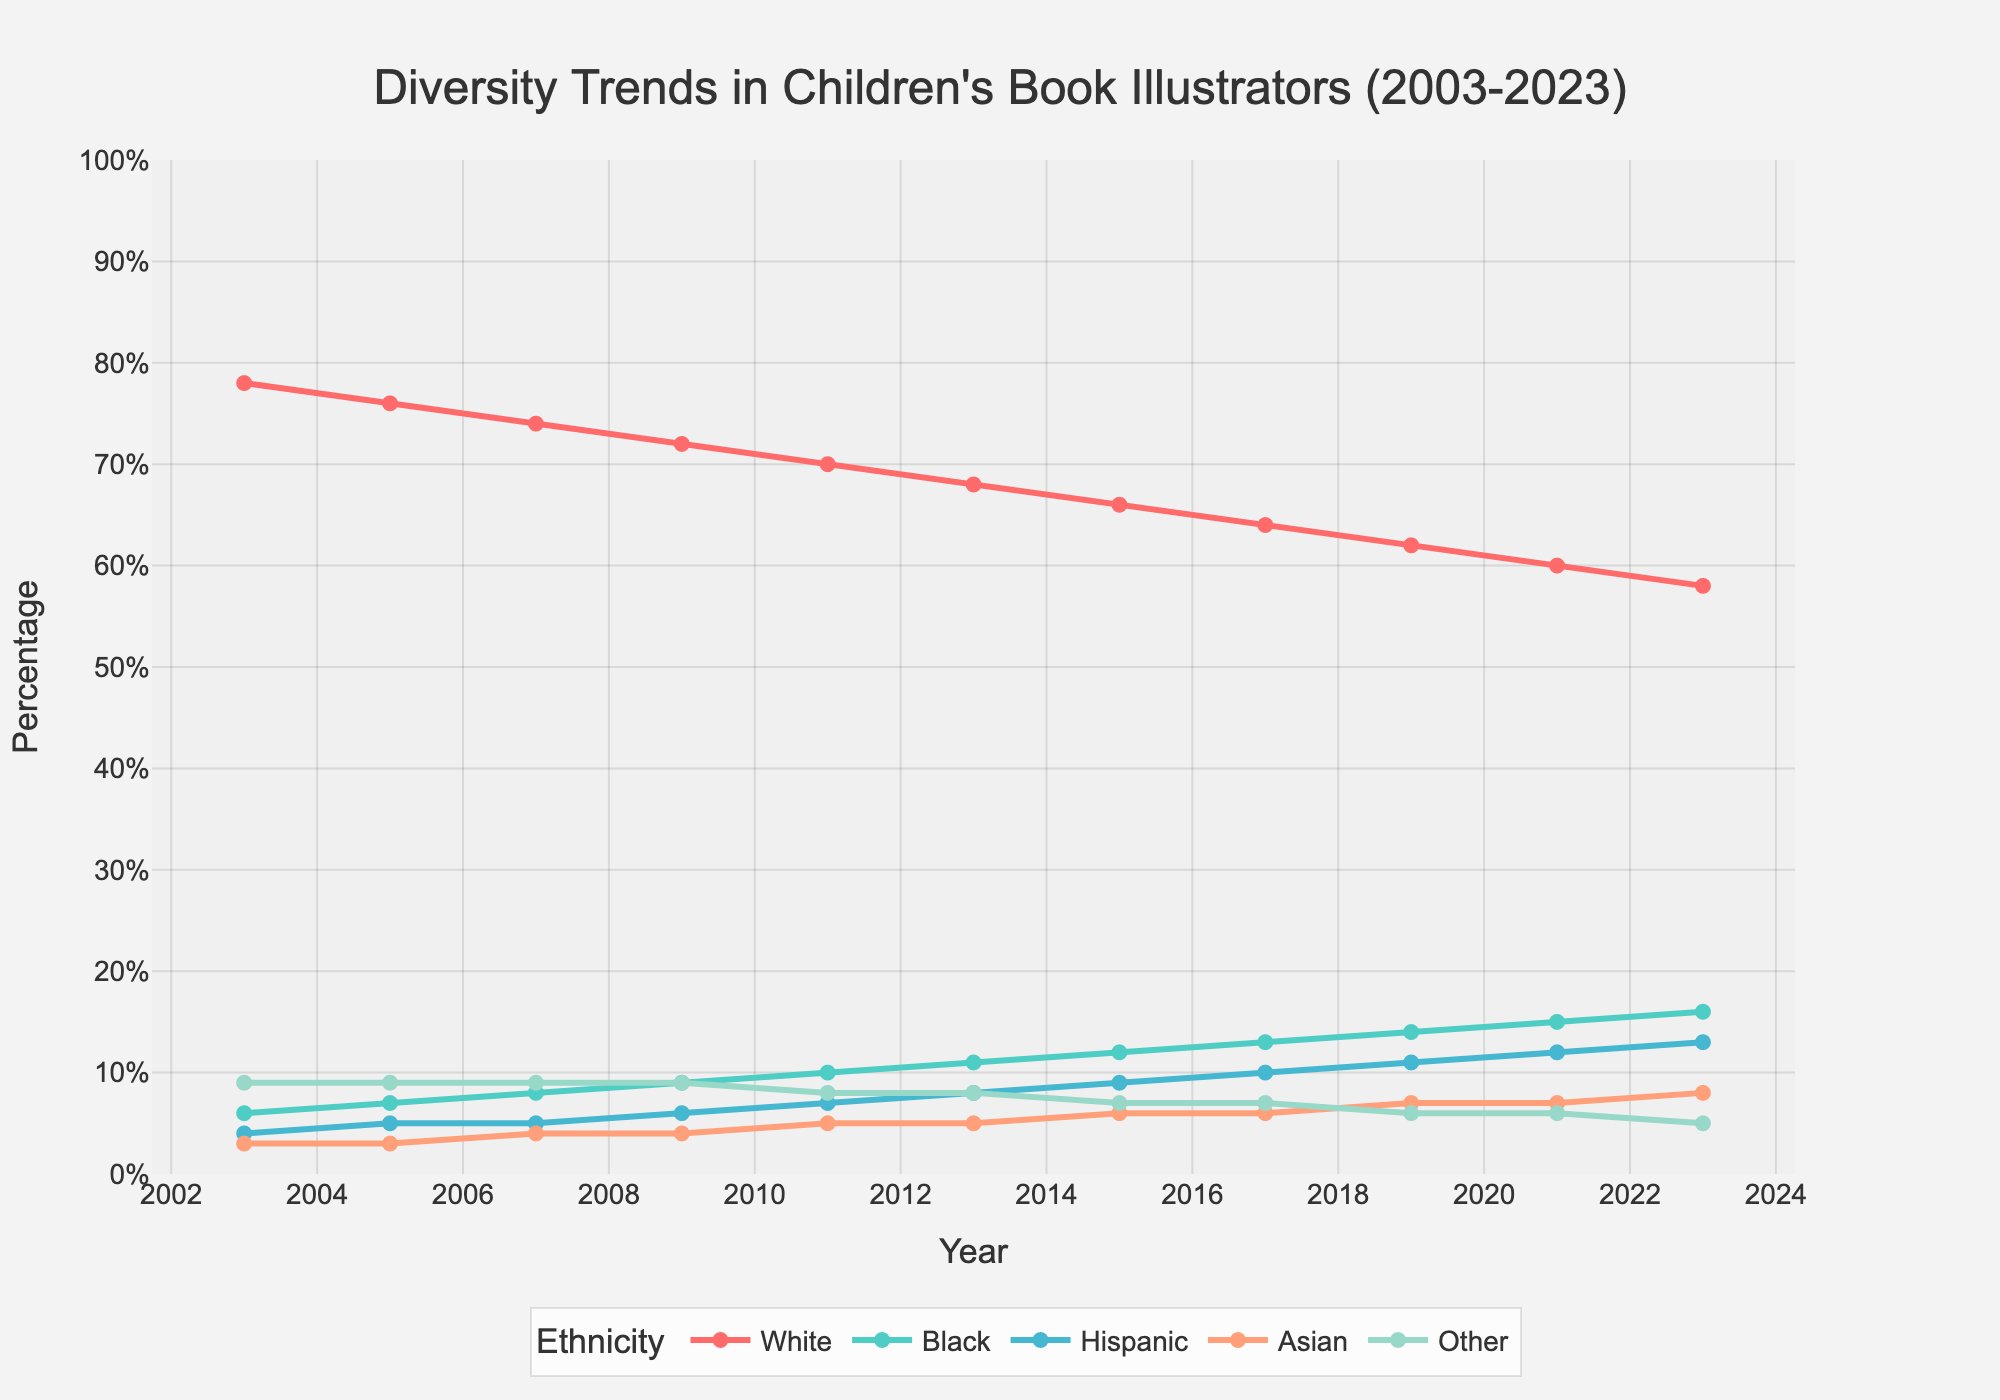What's the percentage decrease of White illustrators from 2003 to 2023? The percentage of White illustrators in 2003 was 78%. In 2023, it was 58%. The decrease is 78% - 58% = 20%.
Answer: 20% Which ethnicity showed a consistent increase in their representation from 2003 to 2023? We observe that all lines representing Black, Hispanic, and Asian illustrators show a consistent increase over the years. Upon direct comparison, the Black illustrators increased every year.
Answer: Black In what year did Hispanic illustrators first reach double-digit percentages? The data shows that Hispanic illustrators first reached 10% in the year 2017.
Answer: 2017 By how many percent did the percentage of Asian illustrators increase from 2003 to 2023? The percentage of Asian illustrators in 2003 was 3%, and in 2023 it was 8%. The increase is 8% - 3% = 5%.
Answer: 5% Which ethnicity had the smallest percentage change from 2003 to 2023? The percentage of the "Other" category went from 9% in 2003 to 5% in 2023, a change of -4%. The other categories had larger changes.
Answer: Other What was the combined percentage of non-White illustrators in 2013? The combined percentage is the sum of Black, Hispanic, Asian, and Other in 2013. Therefore, 11% + 8% + 5% + 8% = 32%.
Answer: 32% Which two ethnicities had nearly equal representation in 2023, and what were their percentages? In 2023, Hispanic and Asian illustrators had nearly equal representation, with percentages of 13% and 8% respectively.
Answer: Hispanic and Asian, 13% and 8% What is the average percentage of Black illustrators between 2003 and 2023? Summing the percentages of Black illustrators across the years: (6 + 7 + 8 + 9 + 10 + 11 + 12 + 13 + 14 + 15 + 16) = 121. Dividing by the number of data points (11), the average percentage is 121/11 ≈ 11%.
Answer: ≈11% Between which consecutive years did White illustrators see the largest drop in their percentage? Comparing the percentages: (2003-2005: 2%, 2005-2007: 2%, 2007-2009: 2%, 2009-2011: 2%, 2011-2013: 2%, 2013-2015: 2%, 2015-2017: 2%, 2017-2019: 2%, 2019-2021: 2%, 2021-2023: 2%). The largest drop of 2% occurred between each pair of years from 2003 to 2023.
Answer: Consistent 2% drops every two years 